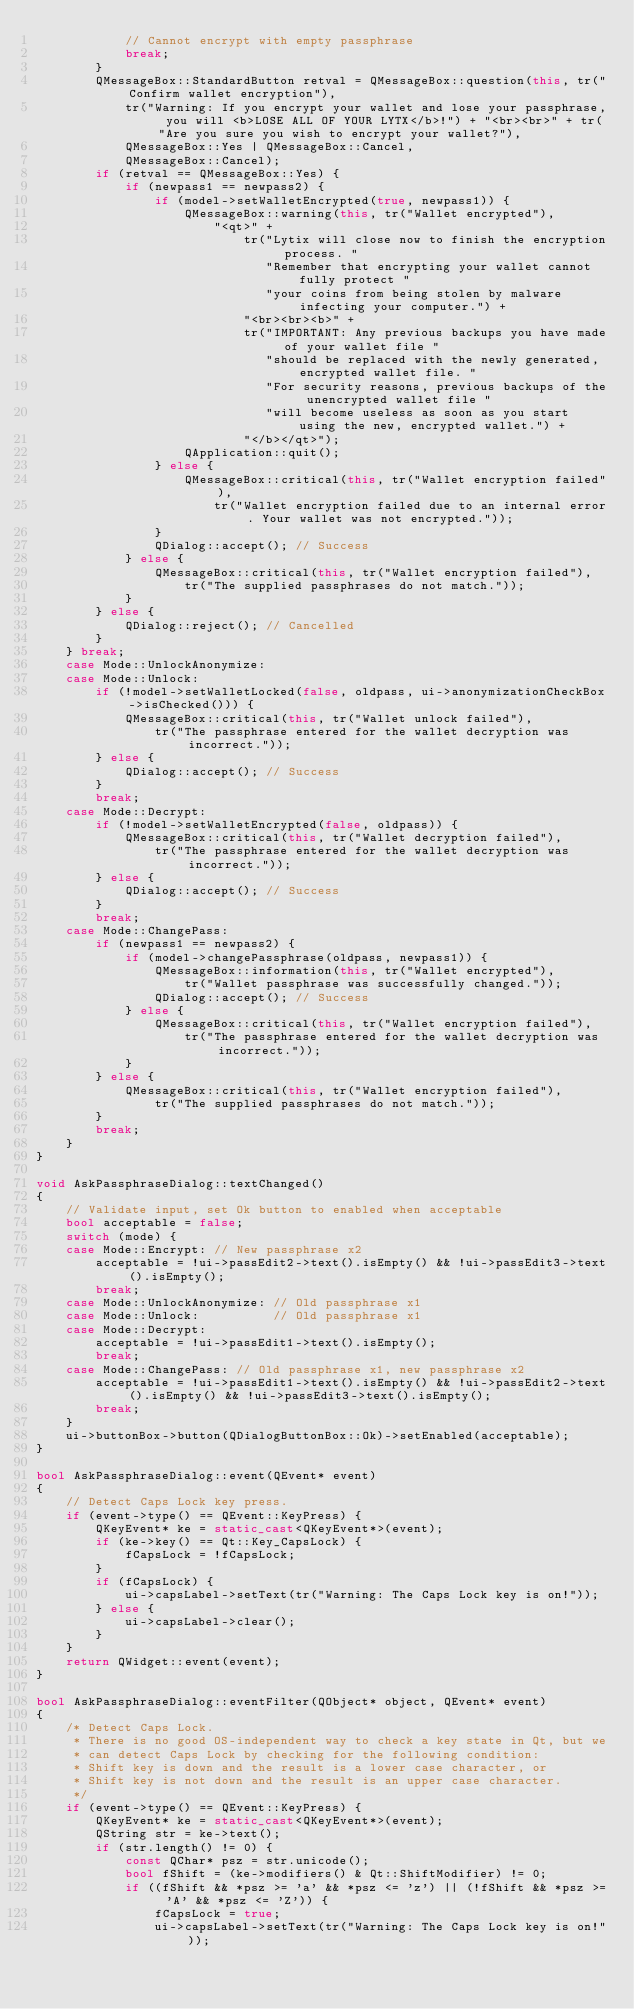<code> <loc_0><loc_0><loc_500><loc_500><_C++_>            // Cannot encrypt with empty passphrase
            break;
        }
        QMessageBox::StandardButton retval = QMessageBox::question(this, tr("Confirm wallet encryption"),
            tr("Warning: If you encrypt your wallet and lose your passphrase, you will <b>LOSE ALL OF YOUR LYTX</b>!") + "<br><br>" + tr("Are you sure you wish to encrypt your wallet?"),
            QMessageBox::Yes | QMessageBox::Cancel,
            QMessageBox::Cancel);
        if (retval == QMessageBox::Yes) {
            if (newpass1 == newpass2) {
                if (model->setWalletEncrypted(true, newpass1)) {
                    QMessageBox::warning(this, tr("Wallet encrypted"),
                        "<qt>" +
                            tr("Lytix will close now to finish the encryption process. "
                               "Remember that encrypting your wallet cannot fully protect "
                               "your coins from being stolen by malware infecting your computer.") +
                            "<br><br><b>" +
                            tr("IMPORTANT: Any previous backups you have made of your wallet file "
                               "should be replaced with the newly generated, encrypted wallet file. "
                               "For security reasons, previous backups of the unencrypted wallet file "
                               "will become useless as soon as you start using the new, encrypted wallet.") +
                            "</b></qt>");
                    QApplication::quit();
                } else {
                    QMessageBox::critical(this, tr("Wallet encryption failed"),
                        tr("Wallet encryption failed due to an internal error. Your wallet was not encrypted."));
                }
                QDialog::accept(); // Success
            } else {
                QMessageBox::critical(this, tr("Wallet encryption failed"),
                    tr("The supplied passphrases do not match."));
            }
        } else {
            QDialog::reject(); // Cancelled
        }
    } break;
    case Mode::UnlockAnonymize:
    case Mode::Unlock:
        if (!model->setWalletLocked(false, oldpass, ui->anonymizationCheckBox->isChecked())) {
            QMessageBox::critical(this, tr("Wallet unlock failed"),
                tr("The passphrase entered for the wallet decryption was incorrect."));
        } else {
            QDialog::accept(); // Success
        }
        break;
    case Mode::Decrypt:
        if (!model->setWalletEncrypted(false, oldpass)) {
            QMessageBox::critical(this, tr("Wallet decryption failed"),
                tr("The passphrase entered for the wallet decryption was incorrect."));
        } else {
            QDialog::accept(); // Success
        }
        break;
    case Mode::ChangePass:
        if (newpass1 == newpass2) {
            if (model->changePassphrase(oldpass, newpass1)) {
                QMessageBox::information(this, tr("Wallet encrypted"),
                    tr("Wallet passphrase was successfully changed."));
                QDialog::accept(); // Success
            } else {
                QMessageBox::critical(this, tr("Wallet encryption failed"),
                    tr("The passphrase entered for the wallet decryption was incorrect."));
            }
        } else {
            QMessageBox::critical(this, tr("Wallet encryption failed"),
                tr("The supplied passphrases do not match."));
        }
        break;
    }
}

void AskPassphraseDialog::textChanged()
{
    // Validate input, set Ok button to enabled when acceptable
    bool acceptable = false;
    switch (mode) {
    case Mode::Encrypt: // New passphrase x2
        acceptable = !ui->passEdit2->text().isEmpty() && !ui->passEdit3->text().isEmpty();
        break;
    case Mode::UnlockAnonymize: // Old passphrase x1
    case Mode::Unlock:          // Old passphrase x1
    case Mode::Decrypt:
        acceptable = !ui->passEdit1->text().isEmpty();
        break;
    case Mode::ChangePass: // Old passphrase x1, new passphrase x2
        acceptable = !ui->passEdit1->text().isEmpty() && !ui->passEdit2->text().isEmpty() && !ui->passEdit3->text().isEmpty();
        break;
    }
    ui->buttonBox->button(QDialogButtonBox::Ok)->setEnabled(acceptable);
}

bool AskPassphraseDialog::event(QEvent* event)
{
    // Detect Caps Lock key press.
    if (event->type() == QEvent::KeyPress) {
        QKeyEvent* ke = static_cast<QKeyEvent*>(event);
        if (ke->key() == Qt::Key_CapsLock) {
            fCapsLock = !fCapsLock;
        }
        if (fCapsLock) {
            ui->capsLabel->setText(tr("Warning: The Caps Lock key is on!"));
        } else {
            ui->capsLabel->clear();
        }
    }
    return QWidget::event(event);
}

bool AskPassphraseDialog::eventFilter(QObject* object, QEvent* event)
{
    /* Detect Caps Lock.
     * There is no good OS-independent way to check a key state in Qt, but we
     * can detect Caps Lock by checking for the following condition:
     * Shift key is down and the result is a lower case character, or
     * Shift key is not down and the result is an upper case character.
     */
    if (event->type() == QEvent::KeyPress) {
        QKeyEvent* ke = static_cast<QKeyEvent*>(event);
        QString str = ke->text();
        if (str.length() != 0) {
            const QChar* psz = str.unicode();
            bool fShift = (ke->modifiers() & Qt::ShiftModifier) != 0;
            if ((fShift && *psz >= 'a' && *psz <= 'z') || (!fShift && *psz >= 'A' && *psz <= 'Z')) {
                fCapsLock = true;
                ui->capsLabel->setText(tr("Warning: The Caps Lock key is on!"));</code> 